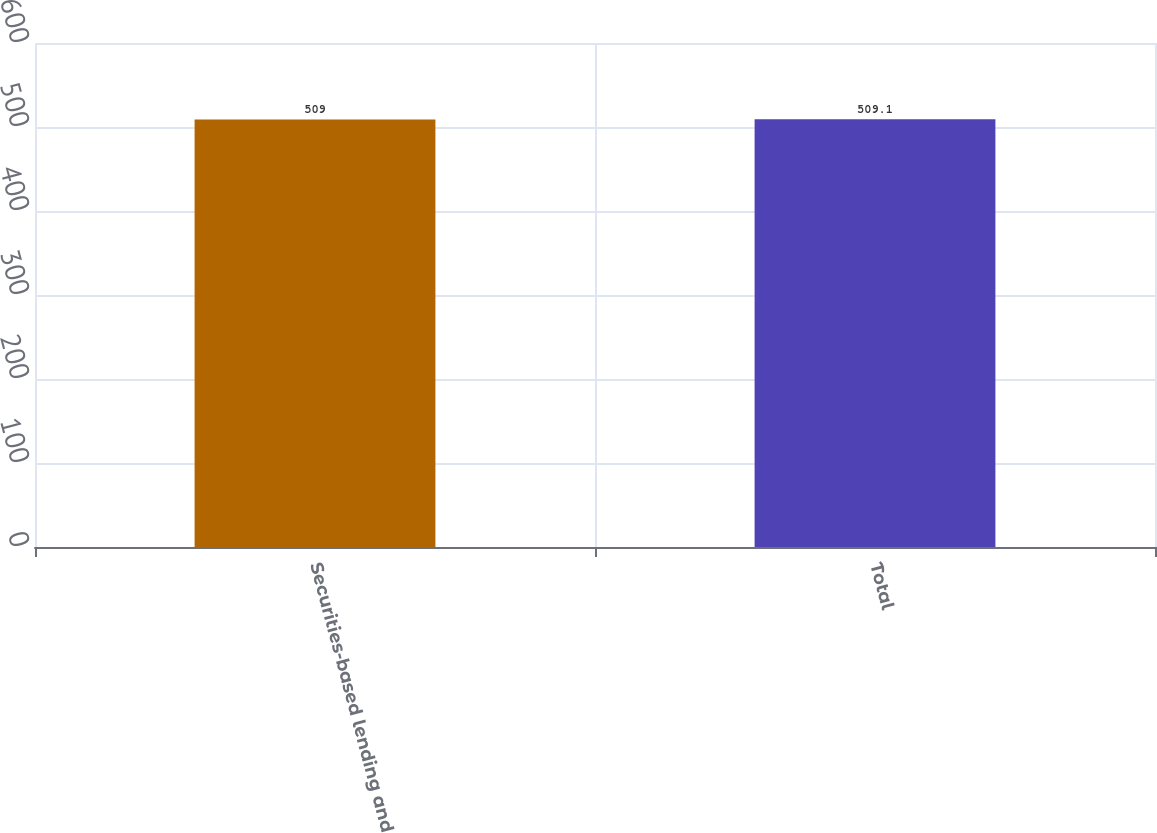Convert chart to OTSL. <chart><loc_0><loc_0><loc_500><loc_500><bar_chart><fcel>Securities-based lending and<fcel>Total<nl><fcel>509<fcel>509.1<nl></chart> 